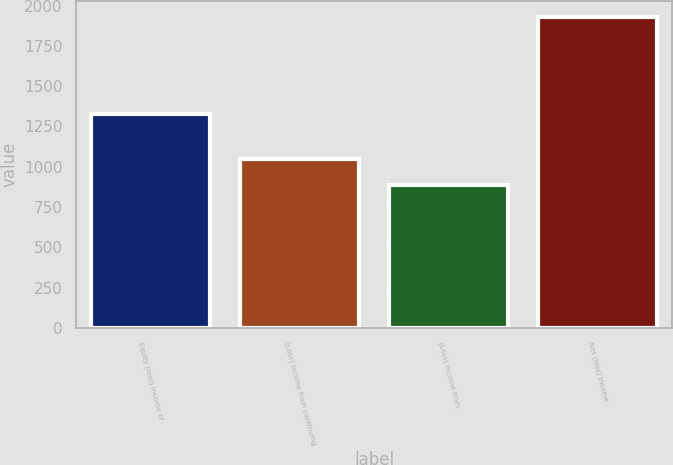Convert chart. <chart><loc_0><loc_0><loc_500><loc_500><bar_chart><fcel>Equity (loss) income of<fcel>(Loss) income from continuing<fcel>(Loss) income from<fcel>Net (loss) income<nl><fcel>1327<fcel>1047<fcel>884<fcel>1931<nl></chart> 